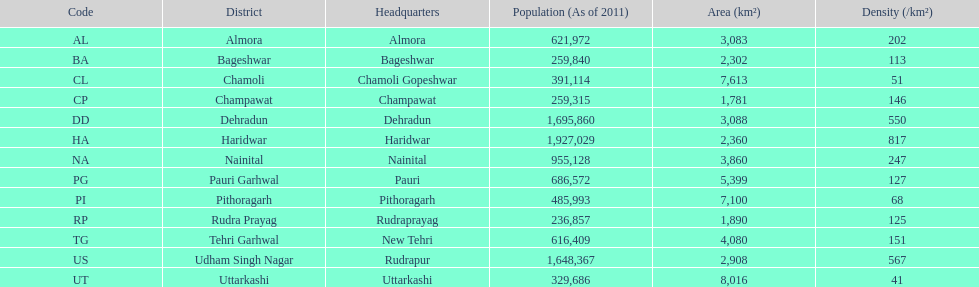Which headquarter has the same district name but has a density of 202? Almora. Could you help me parse every detail presented in this table? {'header': ['Code', 'District', 'Headquarters', 'Population (As of 2011)', 'Area (km²)', 'Density (/km²)'], 'rows': [['AL', 'Almora', 'Almora', '621,972', '3,083', '202'], ['BA', 'Bageshwar', 'Bageshwar', '259,840', '2,302', '113'], ['CL', 'Chamoli', 'Chamoli Gopeshwar', '391,114', '7,613', '51'], ['CP', 'Champawat', 'Champawat', '259,315', '1,781', '146'], ['DD', 'Dehradun', 'Dehradun', '1,695,860', '3,088', '550'], ['HA', 'Haridwar', 'Haridwar', '1,927,029', '2,360', '817'], ['NA', 'Nainital', 'Nainital', '955,128', '3,860', '247'], ['PG', 'Pauri Garhwal', 'Pauri', '686,572', '5,399', '127'], ['PI', 'Pithoragarh', 'Pithoragarh', '485,993', '7,100', '68'], ['RP', 'Rudra Prayag', 'Rudraprayag', '236,857', '1,890', '125'], ['TG', 'Tehri Garhwal', 'New Tehri', '616,409', '4,080', '151'], ['US', 'Udham Singh Nagar', 'Rudrapur', '1,648,367', '2,908', '567'], ['UT', 'Uttarkashi', 'Uttarkashi', '329,686', '8,016', '41']]} 